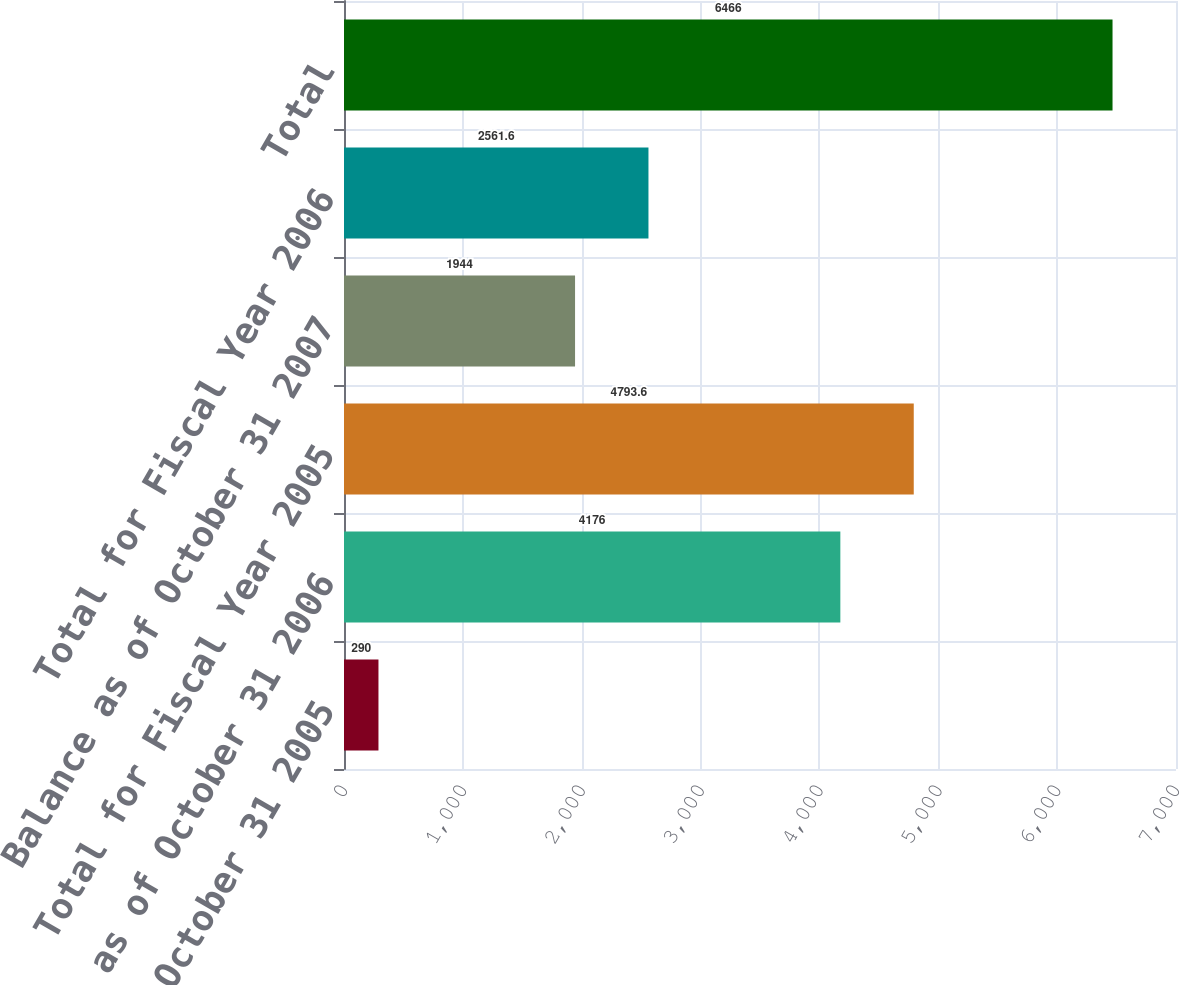<chart> <loc_0><loc_0><loc_500><loc_500><bar_chart><fcel>Balance as of October 31 2005<fcel>Balance as of October 31 2006<fcel>Total for Fiscal Year 2005<fcel>Balance as of October 31 2007<fcel>Total for Fiscal Year 2006<fcel>Total<nl><fcel>290<fcel>4176<fcel>4793.6<fcel>1944<fcel>2561.6<fcel>6466<nl></chart> 